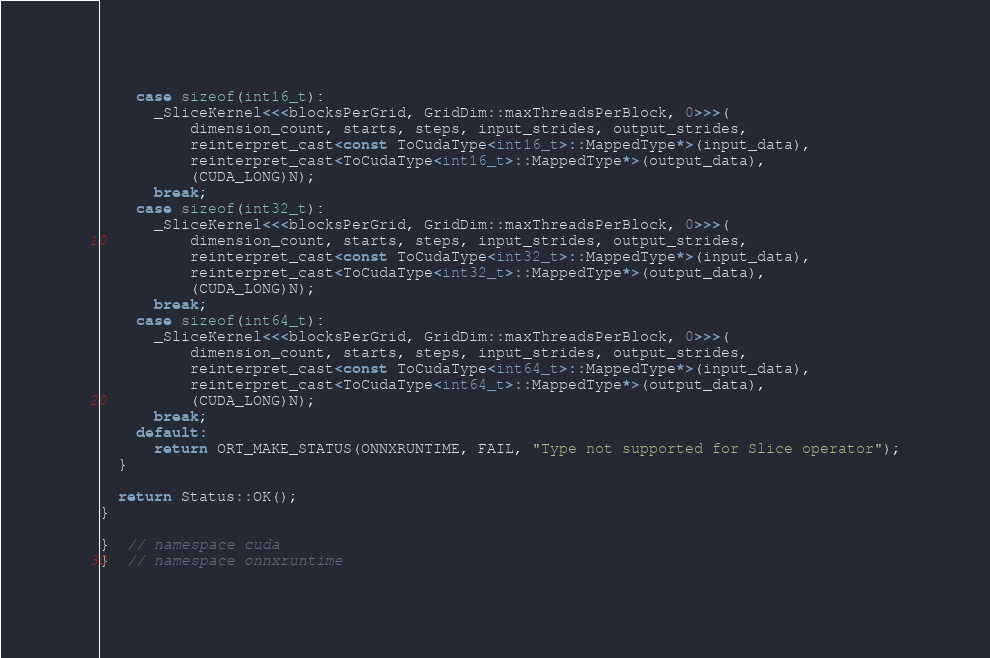Convert code to text. <code><loc_0><loc_0><loc_500><loc_500><_Cuda_>    case sizeof(int16_t):
      _SliceKernel<<<blocksPerGrid, GridDim::maxThreadsPerBlock, 0>>>(
          dimension_count, starts, steps, input_strides, output_strides,
          reinterpret_cast<const ToCudaType<int16_t>::MappedType*>(input_data),
          reinterpret_cast<ToCudaType<int16_t>::MappedType*>(output_data),
          (CUDA_LONG)N);
      break;
    case sizeof(int32_t):
      _SliceKernel<<<blocksPerGrid, GridDim::maxThreadsPerBlock, 0>>>(
          dimension_count, starts, steps, input_strides, output_strides,
          reinterpret_cast<const ToCudaType<int32_t>::MappedType*>(input_data),
          reinterpret_cast<ToCudaType<int32_t>::MappedType*>(output_data),
          (CUDA_LONG)N);
      break;
    case sizeof(int64_t):
      _SliceKernel<<<blocksPerGrid, GridDim::maxThreadsPerBlock, 0>>>(
          dimension_count, starts, steps, input_strides, output_strides,
          reinterpret_cast<const ToCudaType<int64_t>::MappedType*>(input_data),
          reinterpret_cast<ToCudaType<int64_t>::MappedType*>(output_data),
          (CUDA_LONG)N);
      break;
    default:
      return ORT_MAKE_STATUS(ONNXRUNTIME, FAIL, "Type not supported for Slice operator");
  }

  return Status::OK();
}

}  // namespace cuda
}  // namespace onnxruntime
</code> 